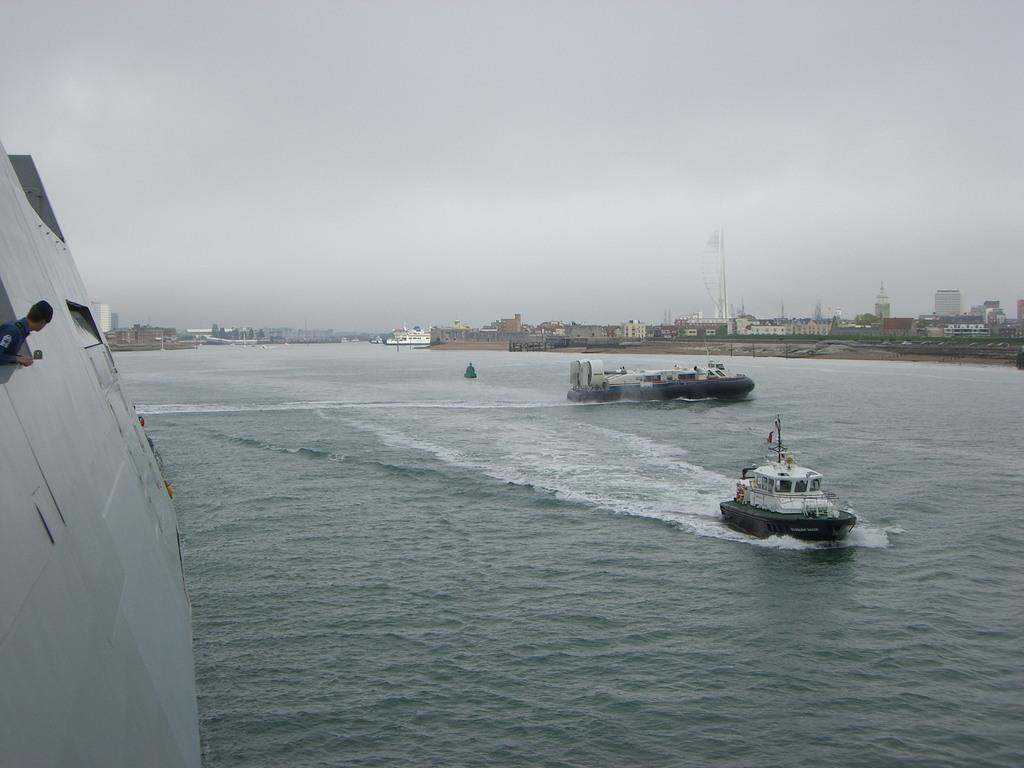What type of vehicles are in the water in the image? There are boats in the water in the image. Can you describe the person's location in the image? There is a person on a ship on the left side of the image. What can be seen in the background of the image? There are buildings and a tower in the background of the image. What type of religious symbol can be seen on the boats in the image? There is no religious symbol present on the boats in the image. How many strings are attached to the tower in the image? There is no string present in the image, as it features boats, a person on a ship, buildings, and a tower. 